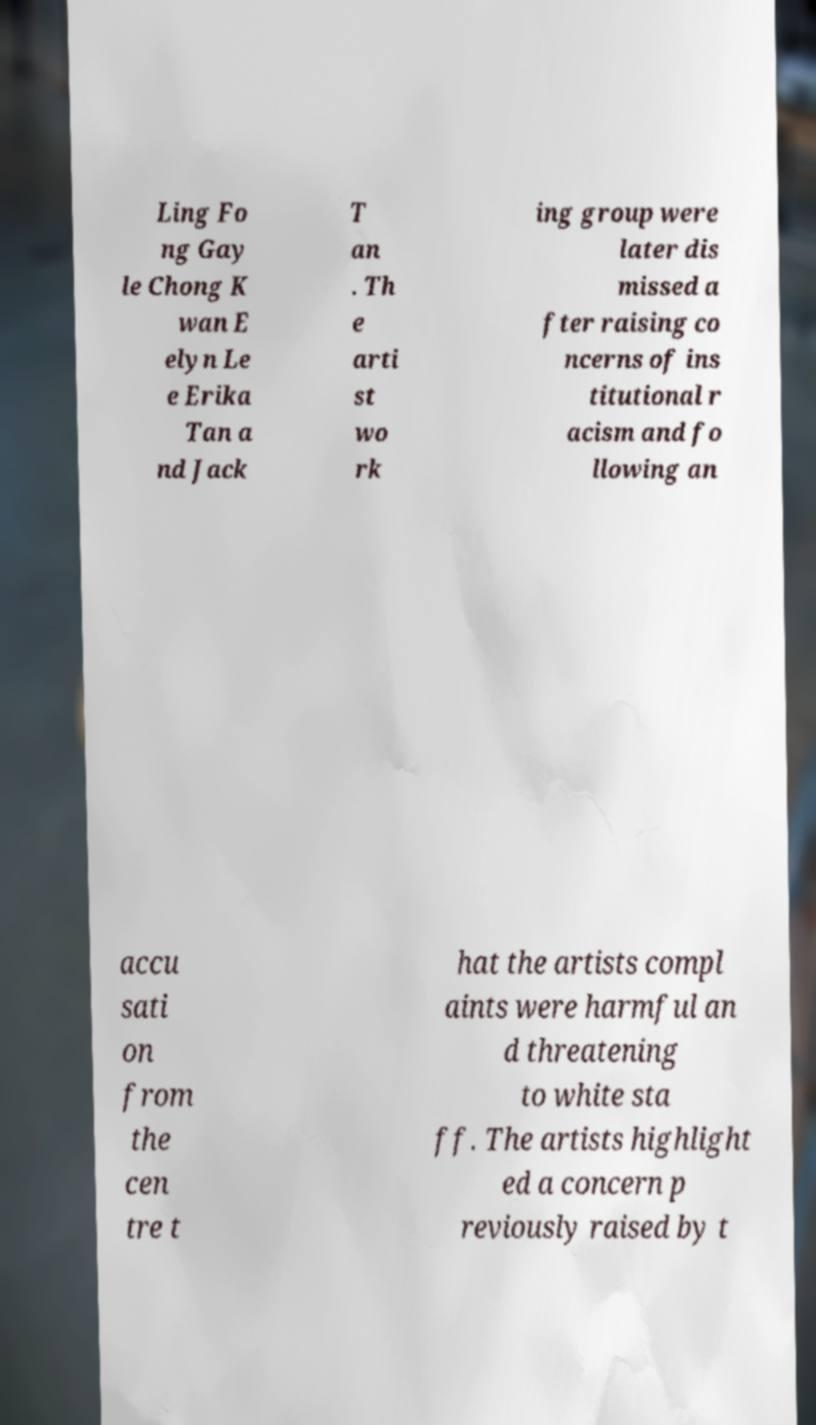Could you assist in decoding the text presented in this image and type it out clearly? Ling Fo ng Gay le Chong K wan E elyn Le e Erika Tan a nd Jack T an . Th e arti st wo rk ing group were later dis missed a fter raising co ncerns of ins titutional r acism and fo llowing an accu sati on from the cen tre t hat the artists compl aints were harmful an d threatening to white sta ff. The artists highlight ed a concern p reviously raised by t 